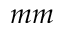Convert formula to latex. <formula><loc_0><loc_0><loc_500><loc_500>m m</formula> 